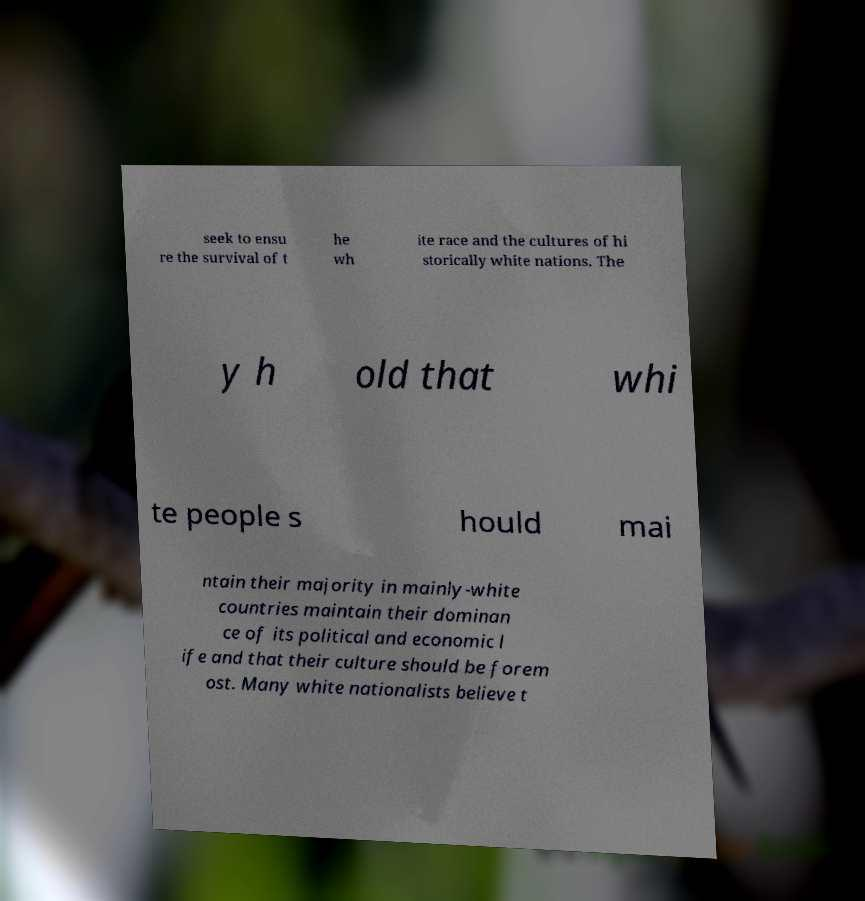For documentation purposes, I need the text within this image transcribed. Could you provide that? seek to ensu re the survival of t he wh ite race and the cultures of hi storically white nations. The y h old that whi te people s hould mai ntain their majority in mainly-white countries maintain their dominan ce of its political and economic l ife and that their culture should be forem ost. Many white nationalists believe t 